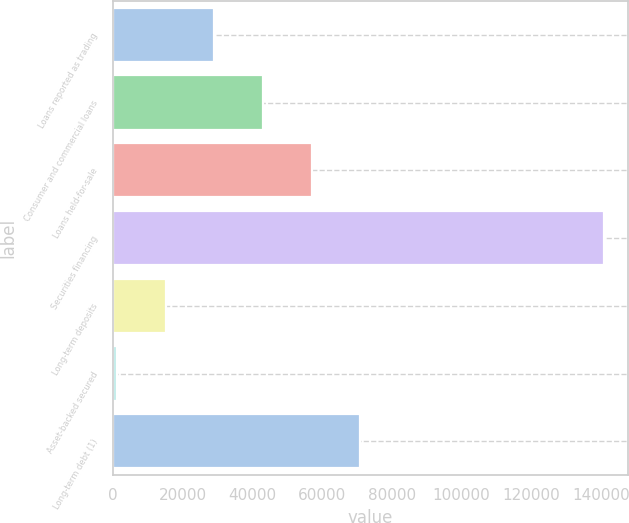Convert chart. <chart><loc_0><loc_0><loc_500><loc_500><bar_chart><fcel>Loans reported as trading<fcel>Consumer and commercial loans<fcel>Loans held-for-sale<fcel>Securities financing<fcel>Long-term deposits<fcel>Asset-backed secured<fcel>Long-term debt (1)<nl><fcel>29099<fcel>43060.5<fcel>57022<fcel>140791<fcel>15137.5<fcel>1176<fcel>70983.5<nl></chart> 